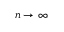<formula> <loc_0><loc_0><loc_500><loc_500>n \rightarrow \infty ,</formula> 